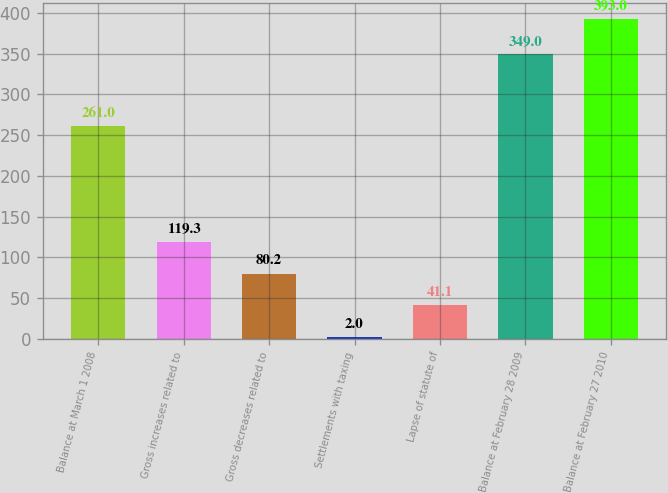Convert chart. <chart><loc_0><loc_0><loc_500><loc_500><bar_chart><fcel>Balance at March 1 2008<fcel>Gross increases related to<fcel>Gross decreases related to<fcel>Settlements with taxing<fcel>Lapse of statute of<fcel>Balance at February 28 2009<fcel>Balance at February 27 2010<nl><fcel>261<fcel>119.3<fcel>80.2<fcel>2<fcel>41.1<fcel>349<fcel>393<nl></chart> 